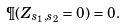Convert formula to latex. <formula><loc_0><loc_0><loc_500><loc_500>\P ( Z _ { s _ { 1 } , s _ { 2 } } = 0 ) = 0 .</formula> 